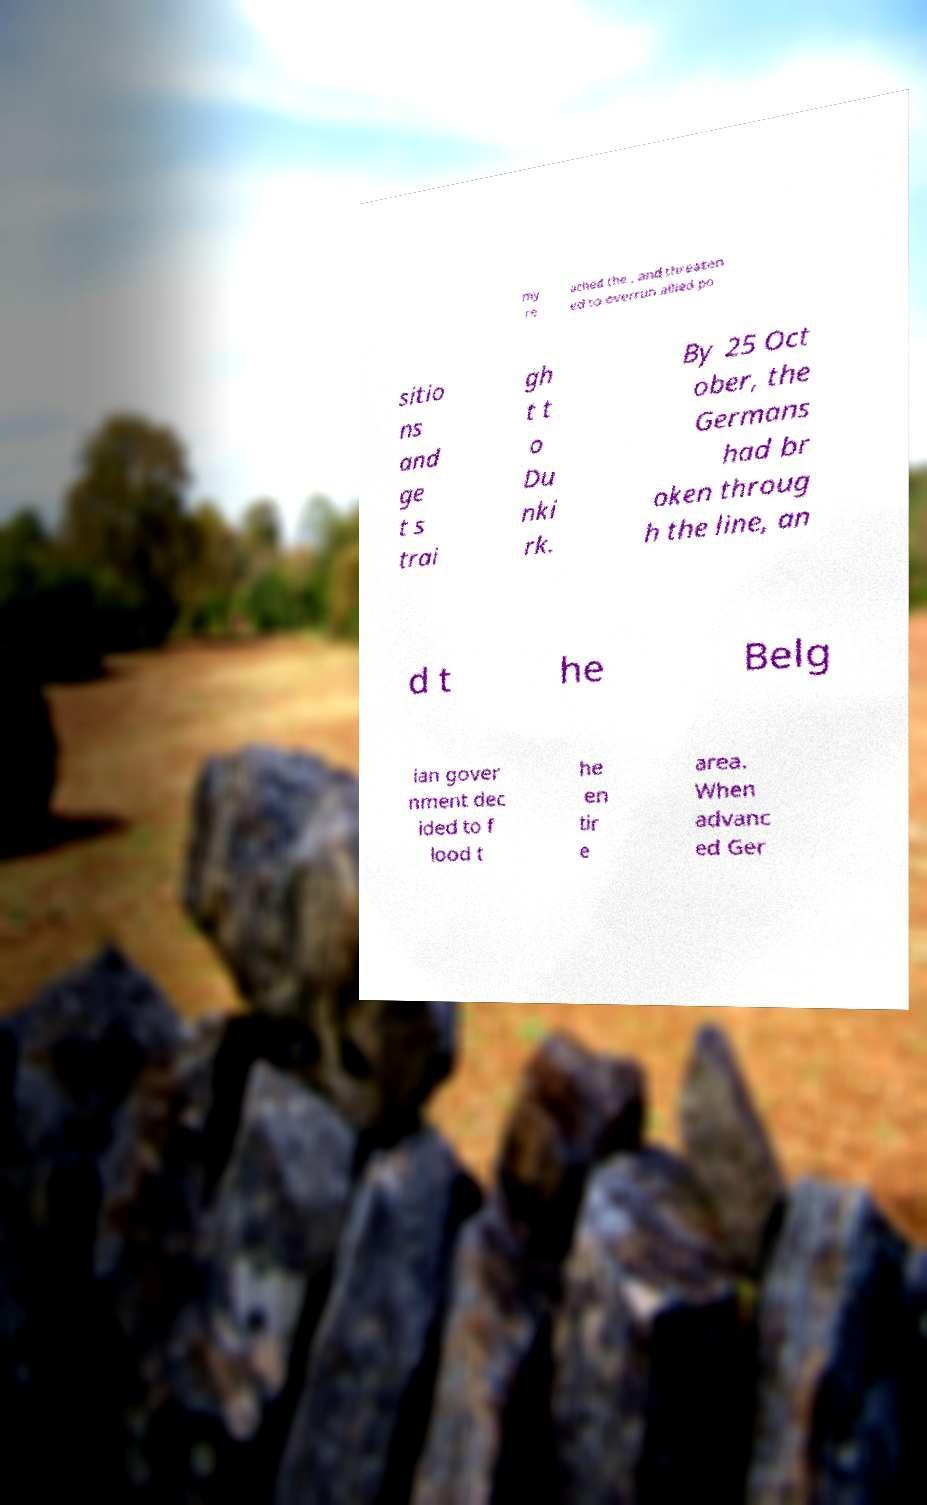Please identify and transcribe the text found in this image. my re ached the , and threaten ed to overrun allied po sitio ns and ge t s trai gh t t o Du nki rk. By 25 Oct ober, the Germans had br oken throug h the line, an d t he Belg ian gover nment dec ided to f lood t he en tir e area. When advanc ed Ger 